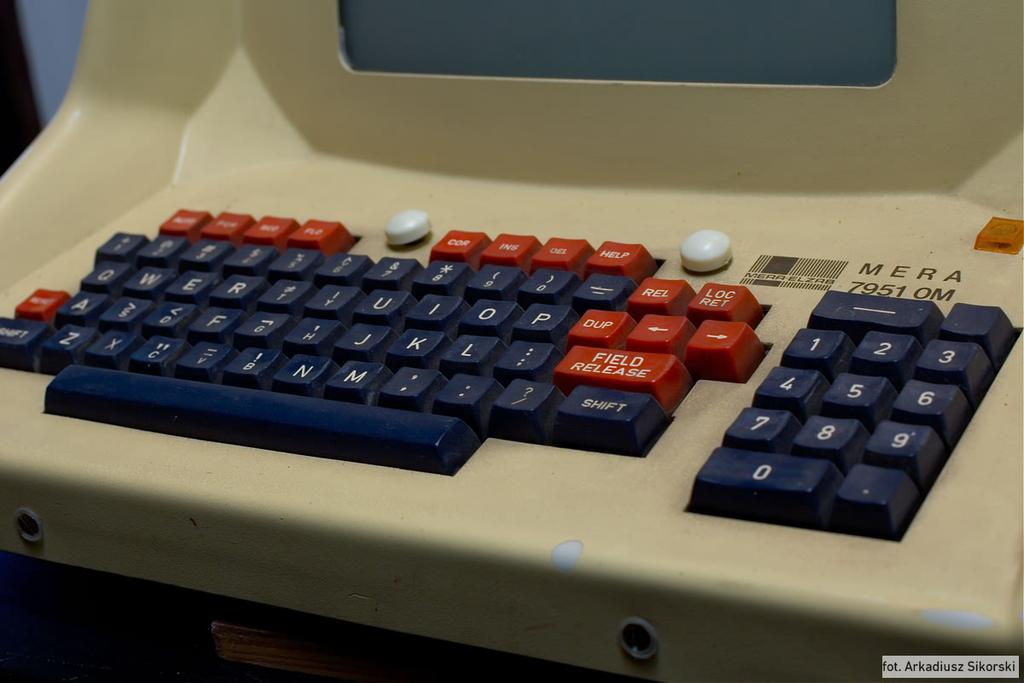<image>
Create a compact narrative representing the image presented. mera 7951 om beige computer terminal with black and red keys 